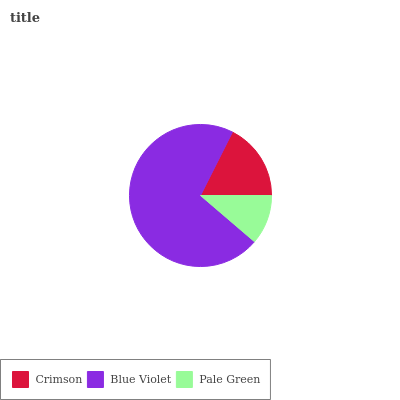Is Pale Green the minimum?
Answer yes or no. Yes. Is Blue Violet the maximum?
Answer yes or no. Yes. Is Blue Violet the minimum?
Answer yes or no. No. Is Pale Green the maximum?
Answer yes or no. No. Is Blue Violet greater than Pale Green?
Answer yes or no. Yes. Is Pale Green less than Blue Violet?
Answer yes or no. Yes. Is Pale Green greater than Blue Violet?
Answer yes or no. No. Is Blue Violet less than Pale Green?
Answer yes or no. No. Is Crimson the high median?
Answer yes or no. Yes. Is Crimson the low median?
Answer yes or no. Yes. Is Pale Green the high median?
Answer yes or no. No. Is Pale Green the low median?
Answer yes or no. No. 